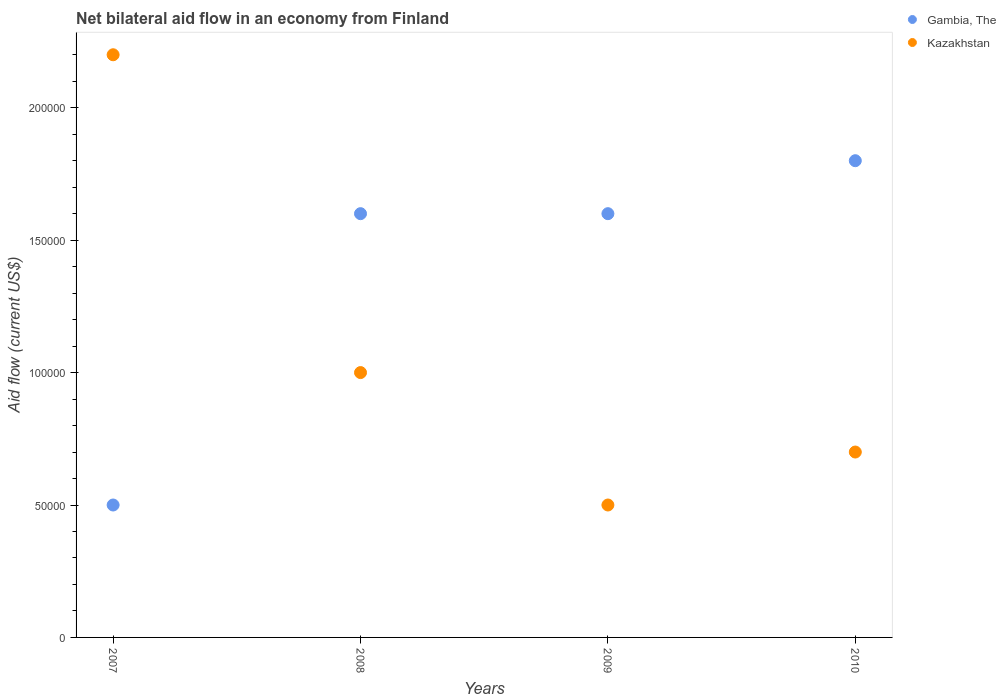What is the difference between the net bilateral aid flow in Gambia, The in 2008 and the net bilateral aid flow in Kazakhstan in 2010?
Make the answer very short. 9.00e+04. What is the average net bilateral aid flow in Gambia, The per year?
Provide a succinct answer. 1.38e+05. In the year 2010, what is the difference between the net bilateral aid flow in Kazakhstan and net bilateral aid flow in Gambia, The?
Provide a succinct answer. -1.10e+05. In how many years, is the net bilateral aid flow in Kazakhstan greater than 70000 US$?
Give a very brief answer. 2. What is the ratio of the net bilateral aid flow in Gambia, The in 2009 to that in 2010?
Offer a terse response. 0.89. Is the difference between the net bilateral aid flow in Kazakhstan in 2008 and 2010 greater than the difference between the net bilateral aid flow in Gambia, The in 2008 and 2010?
Make the answer very short. Yes. What is the difference between the highest and the second highest net bilateral aid flow in Gambia, The?
Provide a succinct answer. 2.00e+04. In how many years, is the net bilateral aid flow in Gambia, The greater than the average net bilateral aid flow in Gambia, The taken over all years?
Provide a short and direct response. 3. Is the sum of the net bilateral aid flow in Kazakhstan in 2007 and 2010 greater than the maximum net bilateral aid flow in Gambia, The across all years?
Ensure brevity in your answer.  Yes. Is the net bilateral aid flow in Gambia, The strictly greater than the net bilateral aid flow in Kazakhstan over the years?
Ensure brevity in your answer.  No. Is the net bilateral aid flow in Kazakhstan strictly less than the net bilateral aid flow in Gambia, The over the years?
Your response must be concise. No. How many dotlines are there?
Your answer should be very brief. 2. How many years are there in the graph?
Make the answer very short. 4. What is the difference between two consecutive major ticks on the Y-axis?
Give a very brief answer. 5.00e+04. Does the graph contain grids?
Your answer should be compact. No. Where does the legend appear in the graph?
Your answer should be compact. Top right. How many legend labels are there?
Your answer should be compact. 2. How are the legend labels stacked?
Your answer should be compact. Vertical. What is the title of the graph?
Ensure brevity in your answer.  Net bilateral aid flow in an economy from Finland. What is the label or title of the X-axis?
Your answer should be compact. Years. What is the Aid flow (current US$) in Gambia, The in 2007?
Offer a very short reply. 5.00e+04. What is the Aid flow (current US$) of Gambia, The in 2008?
Ensure brevity in your answer.  1.60e+05. What is the Aid flow (current US$) of Gambia, The in 2009?
Your answer should be compact. 1.60e+05. What is the Aid flow (current US$) of Kazakhstan in 2010?
Offer a very short reply. 7.00e+04. Across all years, what is the minimum Aid flow (current US$) of Gambia, The?
Offer a very short reply. 5.00e+04. What is the total Aid flow (current US$) of Gambia, The in the graph?
Your answer should be very brief. 5.50e+05. What is the difference between the Aid flow (current US$) in Gambia, The in 2007 and that in 2010?
Your response must be concise. -1.30e+05. What is the difference between the Aid flow (current US$) of Gambia, The in 2008 and that in 2009?
Give a very brief answer. 0. What is the difference between the Aid flow (current US$) of Kazakhstan in 2008 and that in 2009?
Give a very brief answer. 5.00e+04. What is the difference between the Aid flow (current US$) in Gambia, The in 2008 and that in 2010?
Ensure brevity in your answer.  -2.00e+04. What is the difference between the Aid flow (current US$) of Kazakhstan in 2008 and that in 2010?
Provide a succinct answer. 3.00e+04. What is the difference between the Aid flow (current US$) in Gambia, The in 2009 and that in 2010?
Provide a succinct answer. -2.00e+04. What is the difference between the Aid flow (current US$) in Kazakhstan in 2009 and that in 2010?
Ensure brevity in your answer.  -2.00e+04. What is the difference between the Aid flow (current US$) in Gambia, The in 2007 and the Aid flow (current US$) in Kazakhstan in 2008?
Your answer should be compact. -5.00e+04. What is the difference between the Aid flow (current US$) in Gambia, The in 2007 and the Aid flow (current US$) in Kazakhstan in 2010?
Make the answer very short. -2.00e+04. What is the difference between the Aid flow (current US$) of Gambia, The in 2008 and the Aid flow (current US$) of Kazakhstan in 2009?
Provide a succinct answer. 1.10e+05. What is the difference between the Aid flow (current US$) in Gambia, The in 2008 and the Aid flow (current US$) in Kazakhstan in 2010?
Offer a terse response. 9.00e+04. What is the difference between the Aid flow (current US$) in Gambia, The in 2009 and the Aid flow (current US$) in Kazakhstan in 2010?
Ensure brevity in your answer.  9.00e+04. What is the average Aid flow (current US$) in Gambia, The per year?
Offer a very short reply. 1.38e+05. In the year 2008, what is the difference between the Aid flow (current US$) in Gambia, The and Aid flow (current US$) in Kazakhstan?
Provide a short and direct response. 6.00e+04. In the year 2009, what is the difference between the Aid flow (current US$) of Gambia, The and Aid flow (current US$) of Kazakhstan?
Your answer should be very brief. 1.10e+05. In the year 2010, what is the difference between the Aid flow (current US$) of Gambia, The and Aid flow (current US$) of Kazakhstan?
Provide a succinct answer. 1.10e+05. What is the ratio of the Aid flow (current US$) in Gambia, The in 2007 to that in 2008?
Ensure brevity in your answer.  0.31. What is the ratio of the Aid flow (current US$) in Kazakhstan in 2007 to that in 2008?
Ensure brevity in your answer.  2.2. What is the ratio of the Aid flow (current US$) in Gambia, The in 2007 to that in 2009?
Ensure brevity in your answer.  0.31. What is the ratio of the Aid flow (current US$) in Gambia, The in 2007 to that in 2010?
Your response must be concise. 0.28. What is the ratio of the Aid flow (current US$) in Kazakhstan in 2007 to that in 2010?
Your response must be concise. 3.14. What is the ratio of the Aid flow (current US$) in Gambia, The in 2008 to that in 2009?
Provide a succinct answer. 1. What is the ratio of the Aid flow (current US$) in Kazakhstan in 2008 to that in 2009?
Offer a terse response. 2. What is the ratio of the Aid flow (current US$) in Gambia, The in 2008 to that in 2010?
Ensure brevity in your answer.  0.89. What is the ratio of the Aid flow (current US$) of Kazakhstan in 2008 to that in 2010?
Offer a very short reply. 1.43. What is the ratio of the Aid flow (current US$) in Gambia, The in 2009 to that in 2010?
Keep it short and to the point. 0.89. What is the ratio of the Aid flow (current US$) in Kazakhstan in 2009 to that in 2010?
Give a very brief answer. 0.71. What is the difference between the highest and the second highest Aid flow (current US$) of Gambia, The?
Your answer should be very brief. 2.00e+04. What is the difference between the highest and the second highest Aid flow (current US$) of Kazakhstan?
Keep it short and to the point. 1.20e+05. What is the difference between the highest and the lowest Aid flow (current US$) in Gambia, The?
Give a very brief answer. 1.30e+05. What is the difference between the highest and the lowest Aid flow (current US$) of Kazakhstan?
Provide a succinct answer. 1.70e+05. 